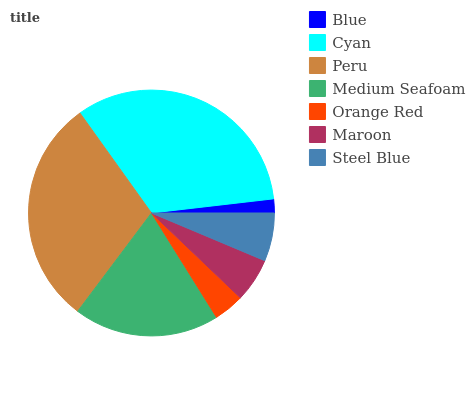Is Blue the minimum?
Answer yes or no. Yes. Is Cyan the maximum?
Answer yes or no. Yes. Is Peru the minimum?
Answer yes or no. No. Is Peru the maximum?
Answer yes or no. No. Is Cyan greater than Peru?
Answer yes or no. Yes. Is Peru less than Cyan?
Answer yes or no. Yes. Is Peru greater than Cyan?
Answer yes or no. No. Is Cyan less than Peru?
Answer yes or no. No. Is Steel Blue the high median?
Answer yes or no. Yes. Is Steel Blue the low median?
Answer yes or no. Yes. Is Medium Seafoam the high median?
Answer yes or no. No. Is Orange Red the low median?
Answer yes or no. No. 